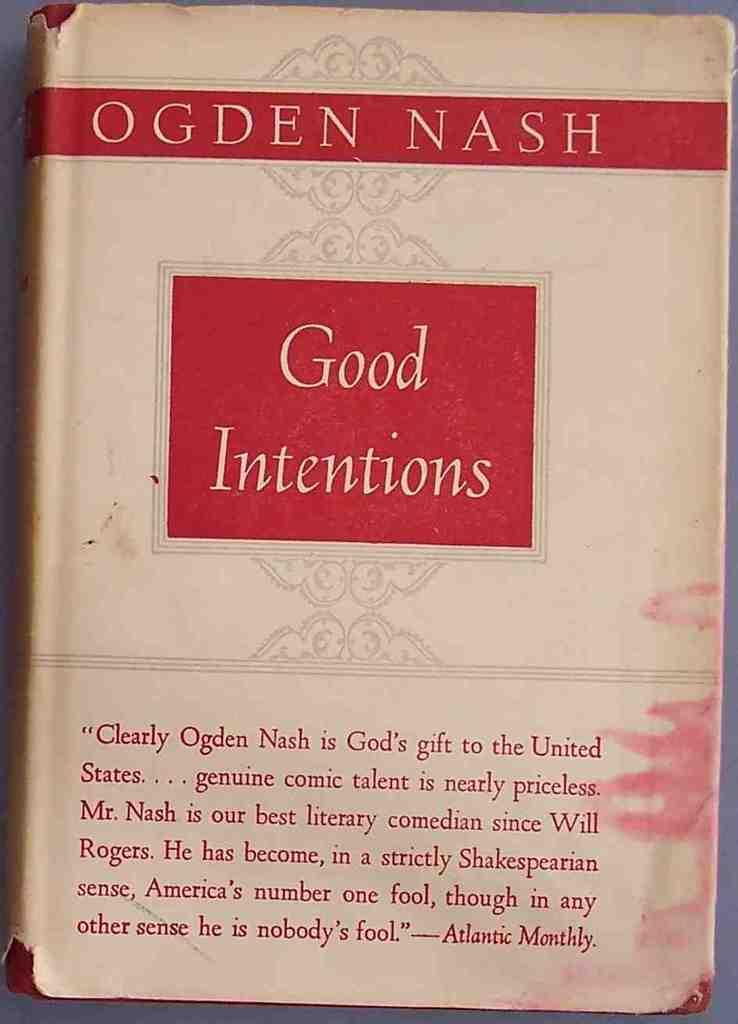What object is present in the image that is typically used for reading or learning? There is a book in the image. Can you describe the position of the book in the image? The book is placed on a surface. What can be seen on the book itself? There is text visible on the book. What type of ticket is required for the trip mentioned in the book? There is no mention of a trip or a ticket in the image or the book. 